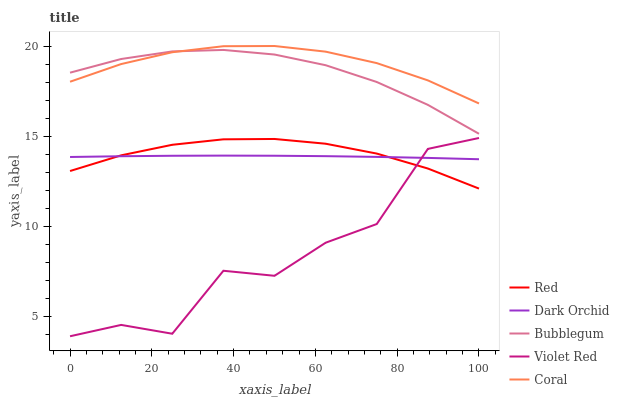Does Violet Red have the minimum area under the curve?
Answer yes or no. Yes. Does Coral have the maximum area under the curve?
Answer yes or no. Yes. Does Bubblegum have the minimum area under the curve?
Answer yes or no. No. Does Bubblegum have the maximum area under the curve?
Answer yes or no. No. Is Dark Orchid the smoothest?
Answer yes or no. Yes. Is Violet Red the roughest?
Answer yes or no. Yes. Is Bubblegum the smoothest?
Answer yes or no. No. Is Bubblegum the roughest?
Answer yes or no. No. Does Violet Red have the lowest value?
Answer yes or no. Yes. Does Bubblegum have the lowest value?
Answer yes or no. No. Does Coral have the highest value?
Answer yes or no. Yes. Does Violet Red have the highest value?
Answer yes or no. No. Is Violet Red less than Coral?
Answer yes or no. Yes. Is Coral greater than Dark Orchid?
Answer yes or no. Yes. Does Red intersect Dark Orchid?
Answer yes or no. Yes. Is Red less than Dark Orchid?
Answer yes or no. No. Is Red greater than Dark Orchid?
Answer yes or no. No. Does Violet Red intersect Coral?
Answer yes or no. No. 